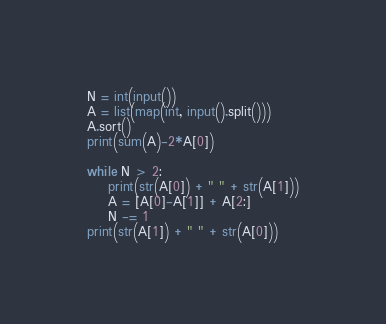<code> <loc_0><loc_0><loc_500><loc_500><_Python_>N = int(input())
A = list(map(int, input().split()))
A.sort()
print(sum(A)-2*A[0])

while N > 2:
    print(str(A[0]) + " " + str(A[1]))
    A = [A[0]-A[1]] + A[2:]
    N -= 1
print(str(A[1]) + " " + str(A[0]))</code> 